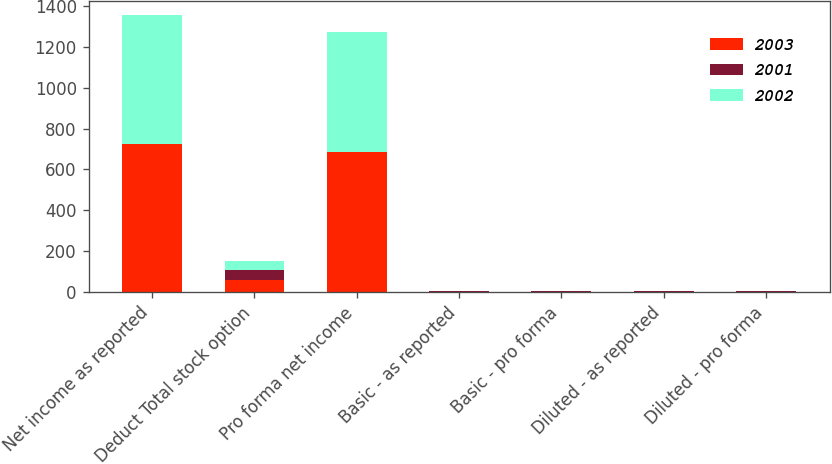Convert chart to OTSL. <chart><loc_0><loc_0><loc_500><loc_500><stacked_bar_chart><ecel><fcel>Net income as reported<fcel>Deduct Total stock option<fcel>Pro forma net income<fcel>Basic - as reported<fcel>Basic - pro forma<fcel>Diluted - as reported<fcel>Diluted - pro forma<nl><fcel>2003<fcel>722<fcel>61<fcel>683<fcel>2.18<fcel>2.06<fcel>2.15<fcel>2.04<nl><fcel>2001<fcel>2.99<fcel>49<fcel>2.99<fcel>3.14<fcel>2.99<fcel>3.1<fcel>2.95<nl><fcel>2002<fcel>628<fcel>43<fcel>585<fcel>1.94<fcel>1.81<fcel>1.9<fcel>1.77<nl></chart> 